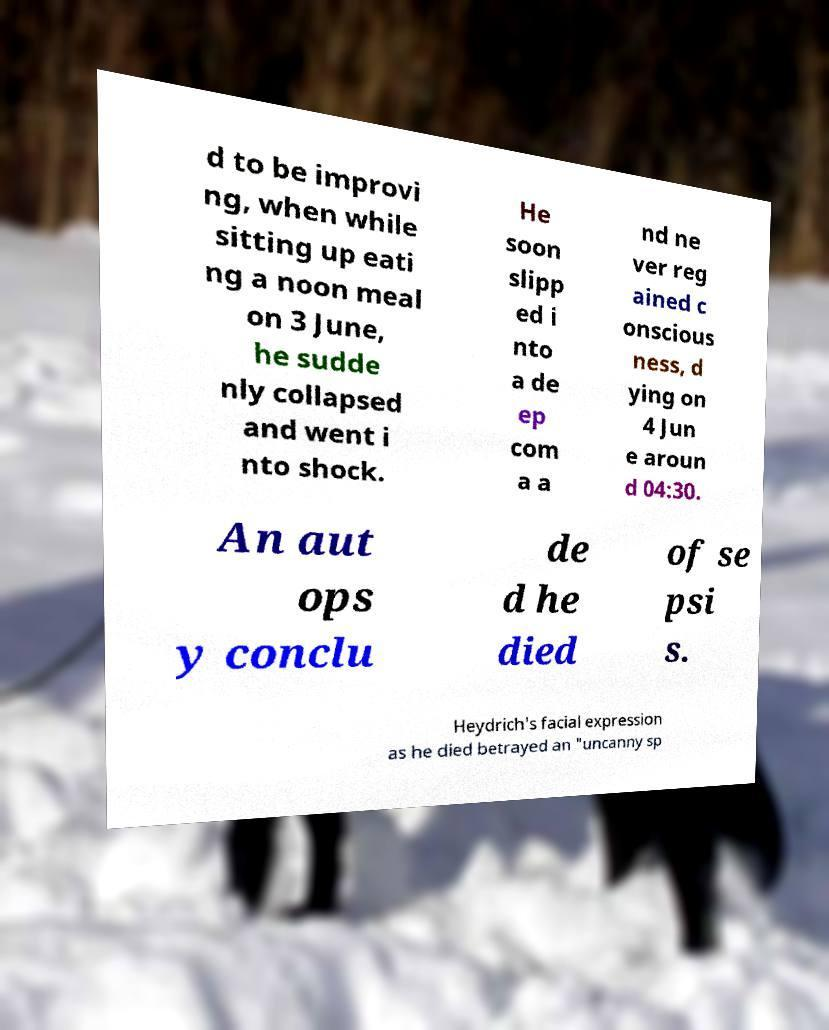There's text embedded in this image that I need extracted. Can you transcribe it verbatim? d to be improvi ng, when while sitting up eati ng a noon meal on 3 June, he sudde nly collapsed and went i nto shock. He soon slipp ed i nto a de ep com a a nd ne ver reg ained c onscious ness, d ying on 4 Jun e aroun d 04:30. An aut ops y conclu de d he died of se psi s. Heydrich's facial expression as he died betrayed an "uncanny sp 